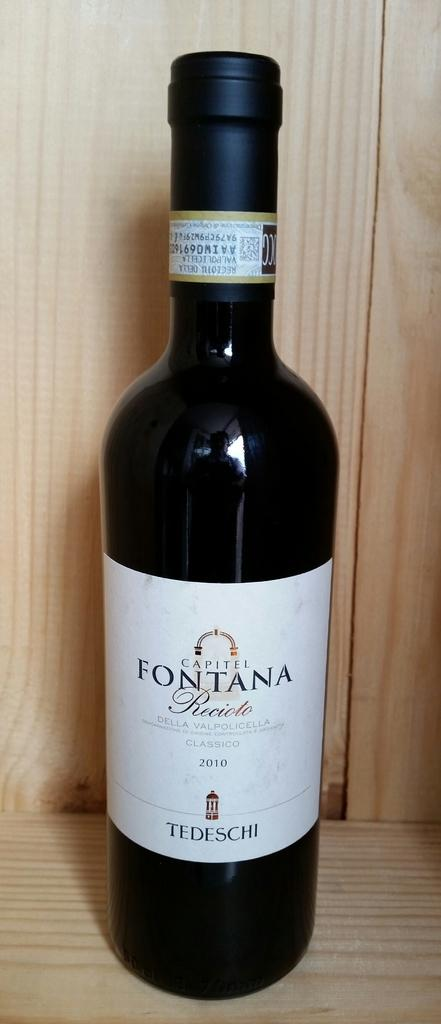Provide a one-sentence caption for the provided image. The Fontana bottle is black with a white label. 